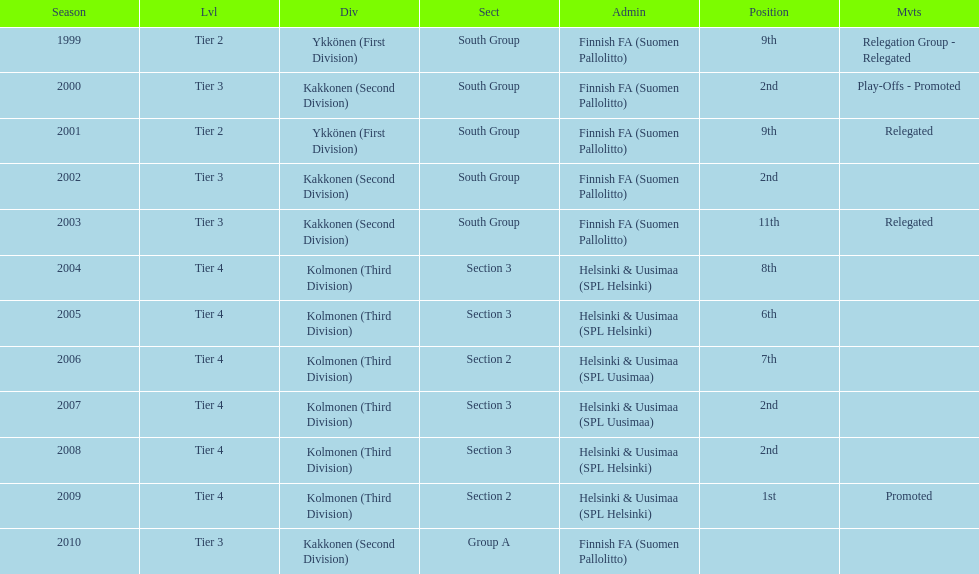When was the last year they placed 2nd? 2008. 